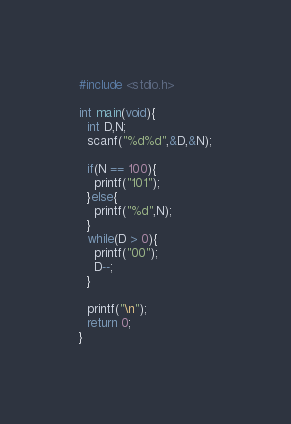<code> <loc_0><loc_0><loc_500><loc_500><_C_>#include <stdio.h>

int main(void){
  int D,N;
  scanf("%d%d",&D,&N);

  if(N == 100){
    printf("101");
  }else{
    printf("%d",N);
  }
  while(D > 0){
    printf("00");
    D--;
  }

  printf("\n");
  return 0;
}</code> 